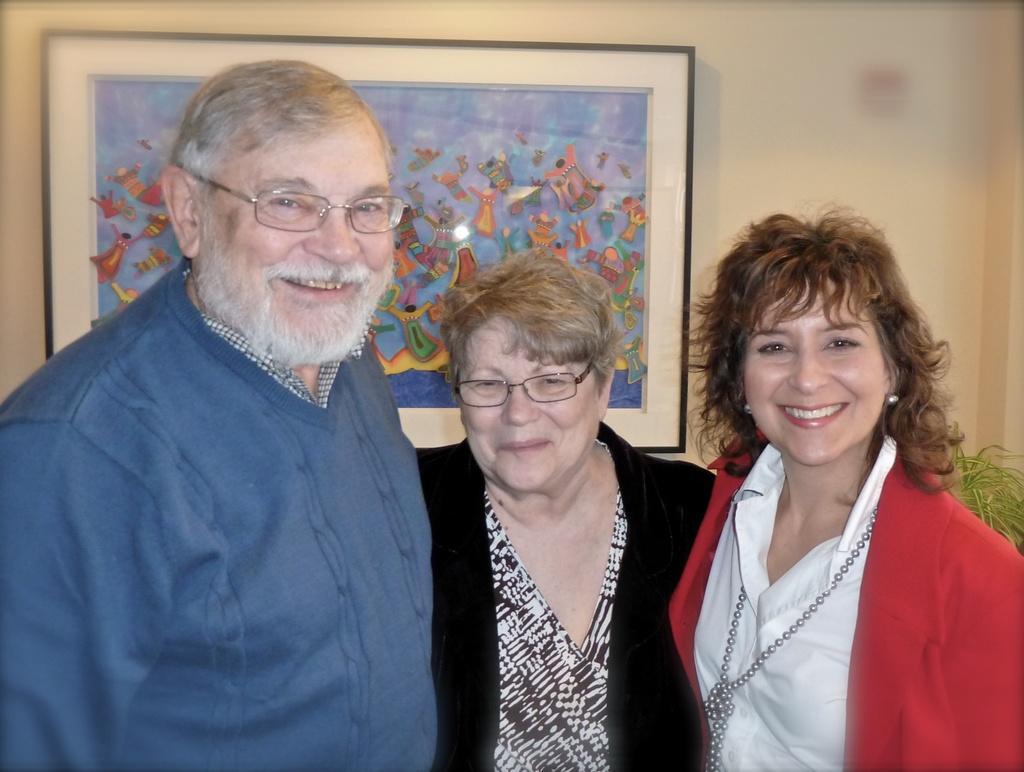Please provide a concise description of this image. In this image I can see three people standing and wearing the different color dresses. These people are smiling and also two people are wearing the specs. In the background there is a frame to the wall. To the right I can see the plant. 